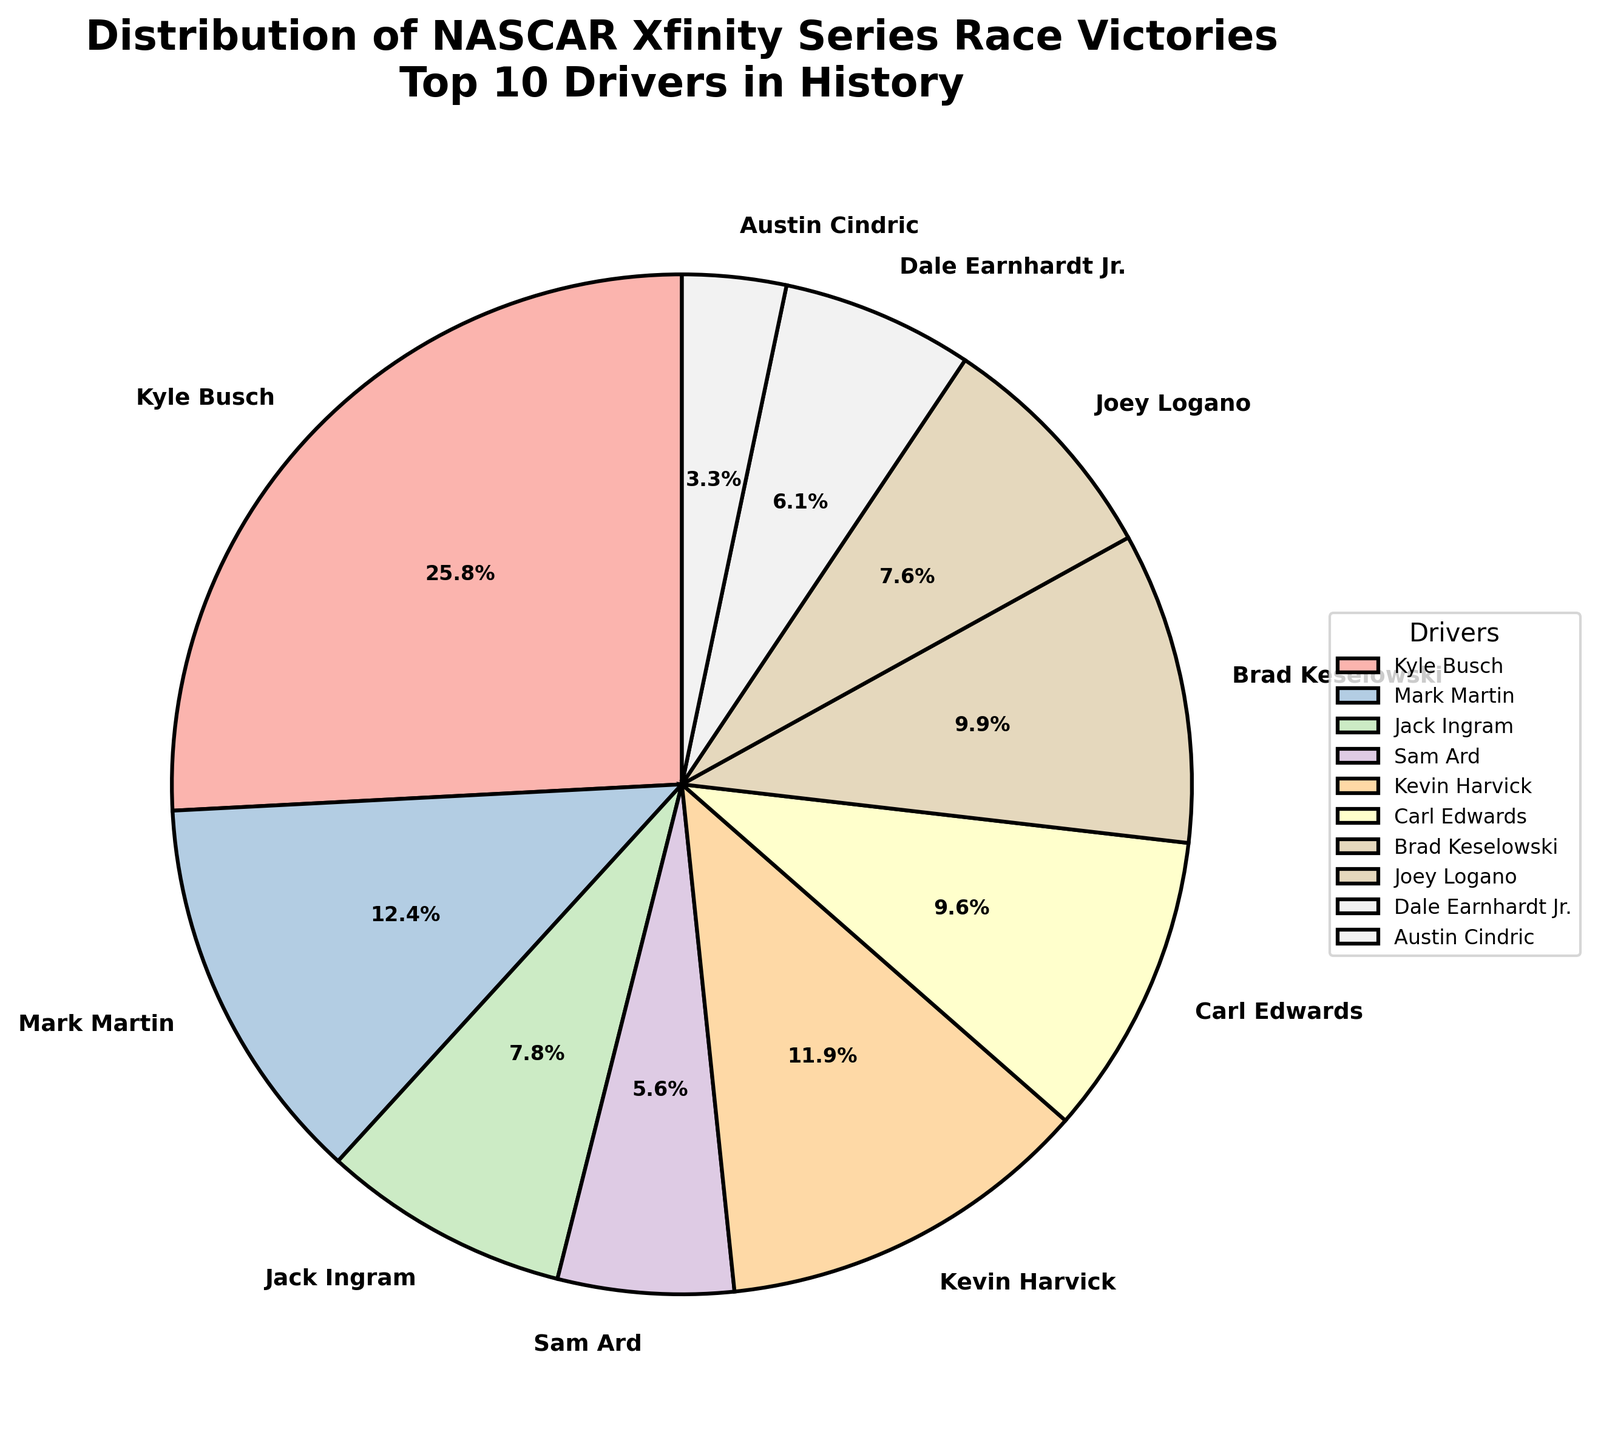What percentage of victories does Kyle Busch have? To find the percentage of victories Kyle Busch has, refer to the pie chart. It shows each segment's value in percentage form. Identify Kyle Busch's segment and note the percentage displayed.
Answer: 35.7% How many more victories does Kyle Busch have compared to Kevin Harvick? Kyle Busch has 102 victories and Kevin Harvick has 47 victories. Subtract Harvick's victories from Busch's victories: 102 - 47.
Answer: 55 Which driver has the third-largest number of victories, and what is their percentage? According to the pie chart, find the driver with the third-largest segment. The segments are usually ordered by size, so the third-largest one should be easy to identify. Locate the percentage label on that segment.
Answer: Jack Ingram, 10.8% Sum the victories of all drivers with fewer than 30 victories. What is the total percentage for these drivers? Identify drivers with fewer than 30 victories: Sam Ard (22), Dale Earnhardt Jr. (24), Austin Cindric (13). Add their victories: 22 + 24 + 13 = 59. Then sum their percentages from the pie chart. Find and sum the corresponding percentages for these drivers.
Answer: 21.8% Who has more victories, Joey Logano or Dale Earnhardt Jr., and by how many? Joey Logano has 30 victories and Dale Earnhardt Jr. has 24 victories. Subtract Earnhardt's victories from Logano's: 30 - 24.
Answer: Joey Logano, 6 What is the combined number of victories for Mark Martin and Brad Keselowski? What percentage of the total victories do they represent? Add the victories of Mark Martin (49) and Brad Keselowski (39): 49 + 39 = 88. Sum their percentages from the pie chart. Mark Martin: 17.1%, Brad Keselowski: 13.6%. Add these percentages: 17.1% + 13.6%.
Answer: 88 victories, 30.7% What is the visual characteristic that distinguishes each driver's segment in the pie chart? Each driver's segment in the pie chart is distinguished by a unique pastel color. The segments also have bold labels displaying the driver's name and percentage of victories. This helps in distinguishing between different segments effectively visually.
Answer: Unique pastel colors and bold labels How does the total percentage of victories by the top 2 drivers compare to the rest of the drivers? Identify the top 2 drivers: Kyle Busch (35.7%) and Mark Martin (17.1%). Sum their percentages: 35.7% + 17.1% = 52.8%. The rest of the drivers' total percentage will be 100% - 52.8%.
Answer: Top 2 drivers: 52.8%, Rest: 47.2% What is the mean number of victories among all 10 drivers? Add up all the victories: 102 (Busch) + 49 (Martin) + 31 (Ingram) + 22 (Ard) + 47 (Harvick) + 38 (Edwards) + 39 (Keselowski) + 30 (Logano) + 24 (Earnhardt) + 13 (Cindric) = 395. Divide by the number of drivers: 395 / 10.
Answer: 39.5 